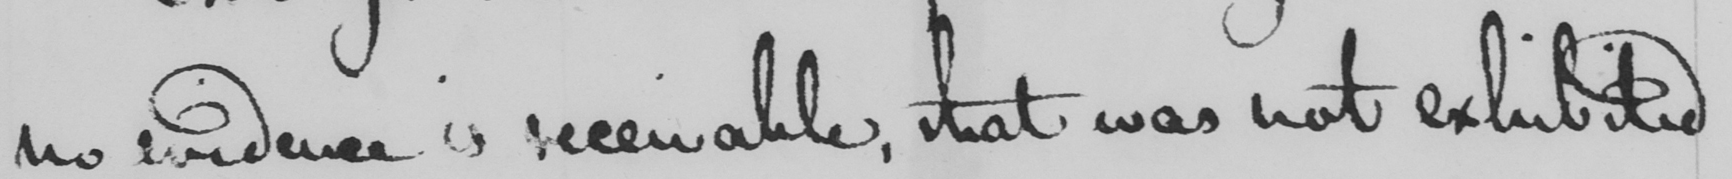Can you read and transcribe this handwriting? no evidence is receivable, that was not exhibited 